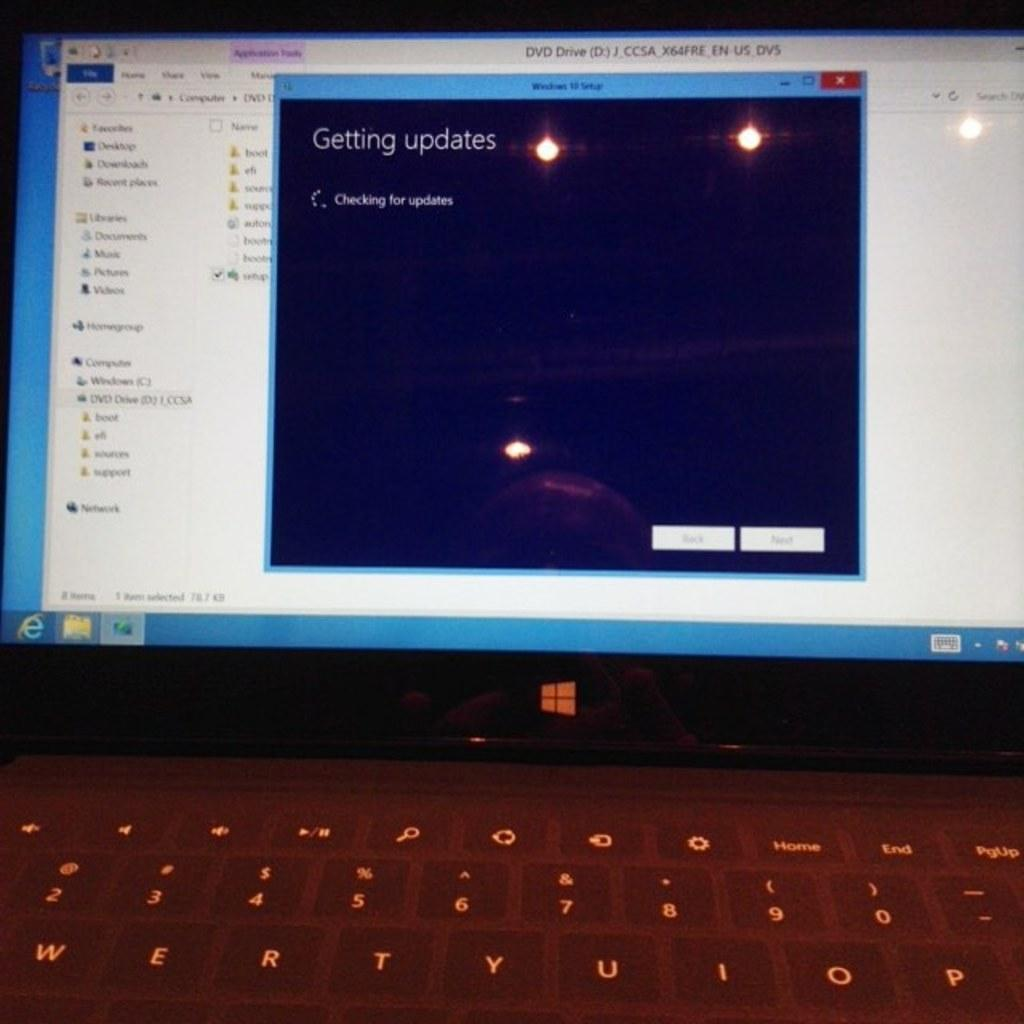<image>
Create a compact narrative representing the image presented. A loading dialog box on a laptop screen states that it is getting updates. 